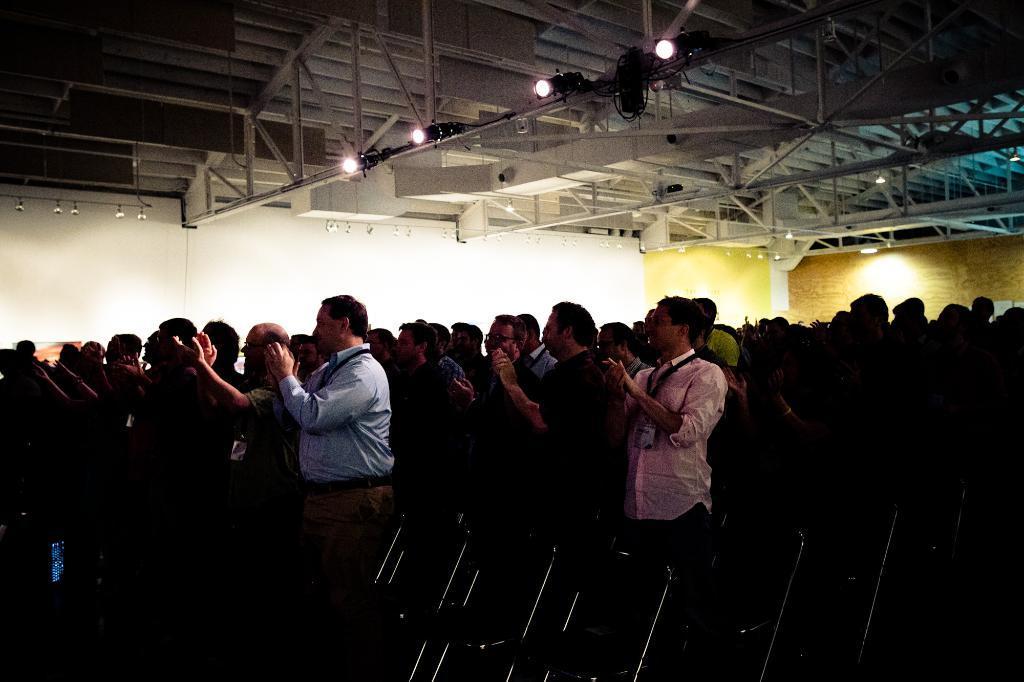Please provide a concise description of this image. Here I can see a crowd of people standing facing towards the left side and clapping their hands. At the bottom there are chairs. In the background there is a wall. At the top of the image I can see the ceiling along with the metal rods and lights. 